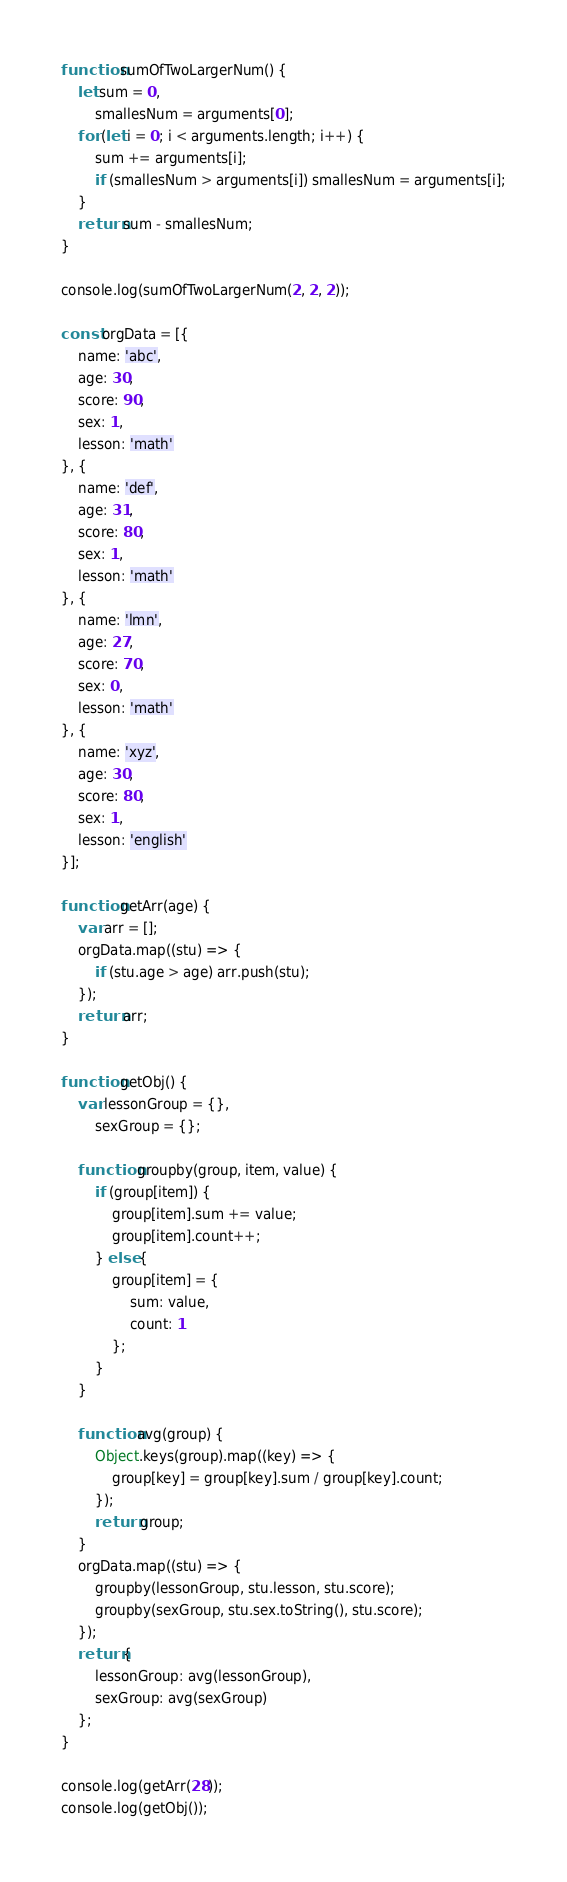Convert code to text. <code><loc_0><loc_0><loc_500><loc_500><_JavaScript_>function sumOfTwoLargerNum() {
    let sum = 0,
        smallesNum = arguments[0];
    for (let i = 0; i < arguments.length; i++) {
        sum += arguments[i];
        if (smallesNum > arguments[i]) smallesNum = arguments[i];
    }
    return sum - smallesNum;
}

console.log(sumOfTwoLargerNum(2, 2, 2));

const orgData = [{
    name: 'abc',
    age: 30,
    score: 90,
    sex: 1,
    lesson: 'math'
}, {
    name: 'def',
    age: 31,
    score: 80,
    sex: 1,
    lesson: 'math'
}, {
    name: 'lmn',
    age: 27,
    score: 70,
    sex: 0,
    lesson: 'math'
}, {
    name: 'xyz',
    age: 30,
    score: 80,
    sex: 1,
    lesson: 'english'
}];

function getArr(age) {
    var arr = [];
    orgData.map((stu) => {
        if (stu.age > age) arr.push(stu);
    });
    return arr;
}

function getObj() {
    var lessonGroup = {},
        sexGroup = {};

    function groupby(group, item, value) {
        if (group[item]) {
            group[item].sum += value;
            group[item].count++;
        } else {
            group[item] = {
                sum: value,
                count: 1
            };
        }
    }

    function avg(group) {
        Object.keys(group).map((key) => {
            group[key] = group[key].sum / group[key].count;
        });
        return group;
    }
    orgData.map((stu) => {
        groupby(lessonGroup, stu.lesson, stu.score);
        groupby(sexGroup, stu.sex.toString(), stu.score);
    });
    return {
        lessonGroup: avg(lessonGroup),
        sexGroup: avg(sexGroup)
    };
}

console.log(getArr(28));
console.log(getObj());
</code> 